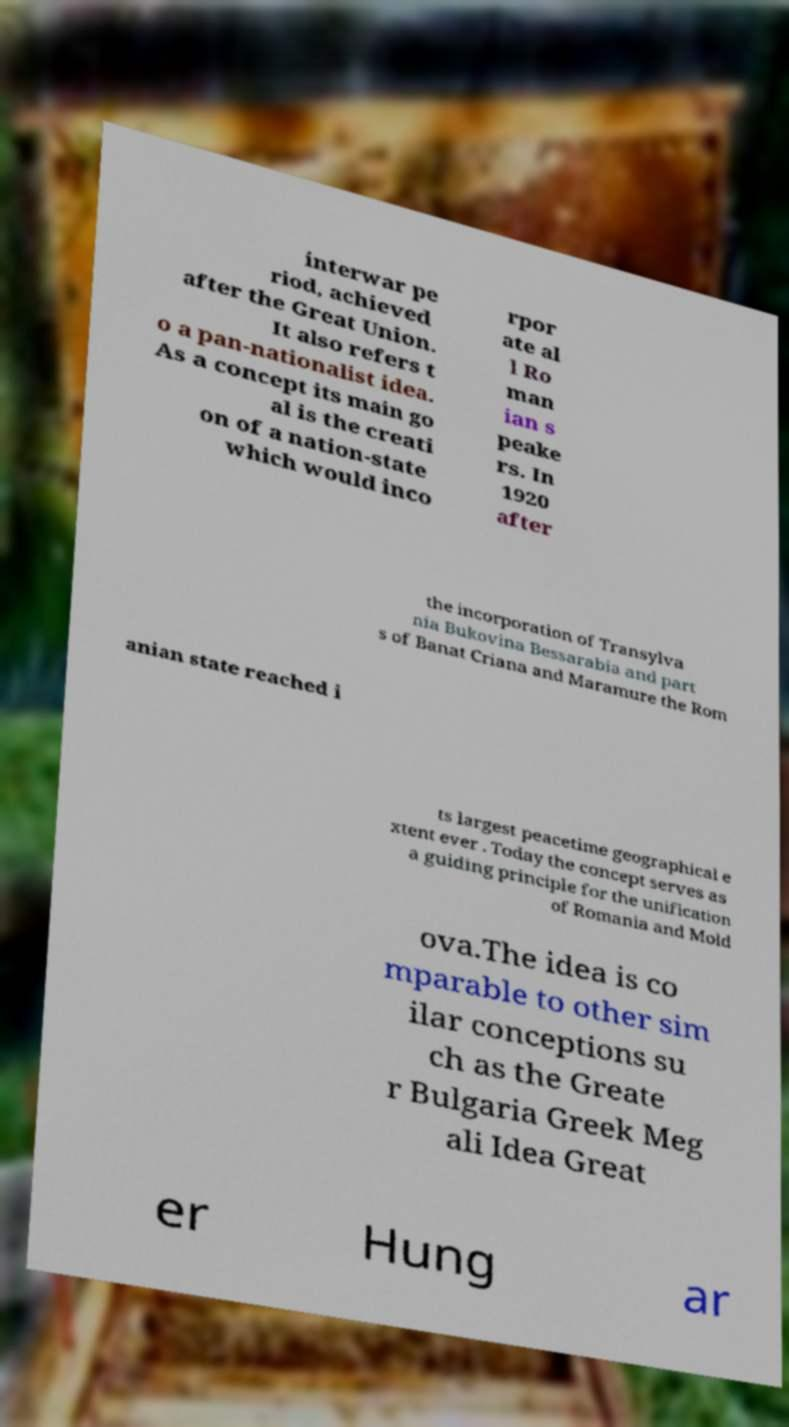What messages or text are displayed in this image? I need them in a readable, typed format. interwar pe riod, achieved after the Great Union. It also refers t o a pan-nationalist idea. As a concept its main go al is the creati on of a nation-state which would inco rpor ate al l Ro man ian s peake rs. In 1920 after the incorporation of Transylva nia Bukovina Bessarabia and part s of Banat Criana and Maramure the Rom anian state reached i ts largest peacetime geographical e xtent ever . Today the concept serves as a guiding principle for the unification of Romania and Mold ova.The idea is co mparable to other sim ilar conceptions su ch as the Greate r Bulgaria Greek Meg ali Idea Great er Hung ar 